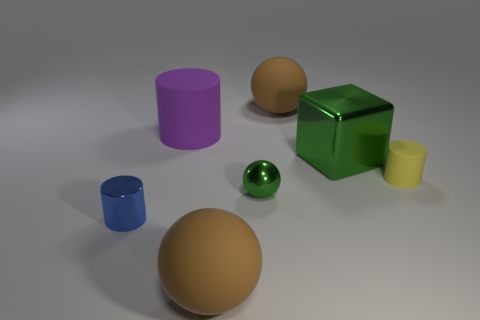Are there fewer big objects that are on the right side of the big purple object than big cyan metallic things?
Provide a short and direct response. No. Is there anything else that is the same shape as the large metal object?
Provide a short and direct response. No. What shape is the green metallic object that is in front of the metal cube?
Your response must be concise. Sphere. The big thing that is in front of the rubber cylinder that is right of the rubber sphere that is to the left of the tiny green ball is what shape?
Provide a short and direct response. Sphere. What number of things are either large cylinders or shiny spheres?
Provide a short and direct response. 2. There is a large object in front of the blue metallic object; does it have the same shape as the brown object behind the small blue shiny cylinder?
Offer a terse response. Yes. What number of matte spheres are both in front of the purple cylinder and behind the tiny rubber cylinder?
Your answer should be compact. 0. How many other things are there of the same size as the cube?
Make the answer very short. 3. What is the big object that is in front of the purple rubber cylinder and to the left of the cube made of?
Ensure brevity in your answer.  Rubber. There is a block; is it the same color as the metallic ball in front of the big block?
Your response must be concise. Yes. 